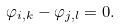Convert formula to latex. <formula><loc_0><loc_0><loc_500><loc_500>\varphi _ { i , k } - \varphi _ { j , l } = 0 .</formula> 